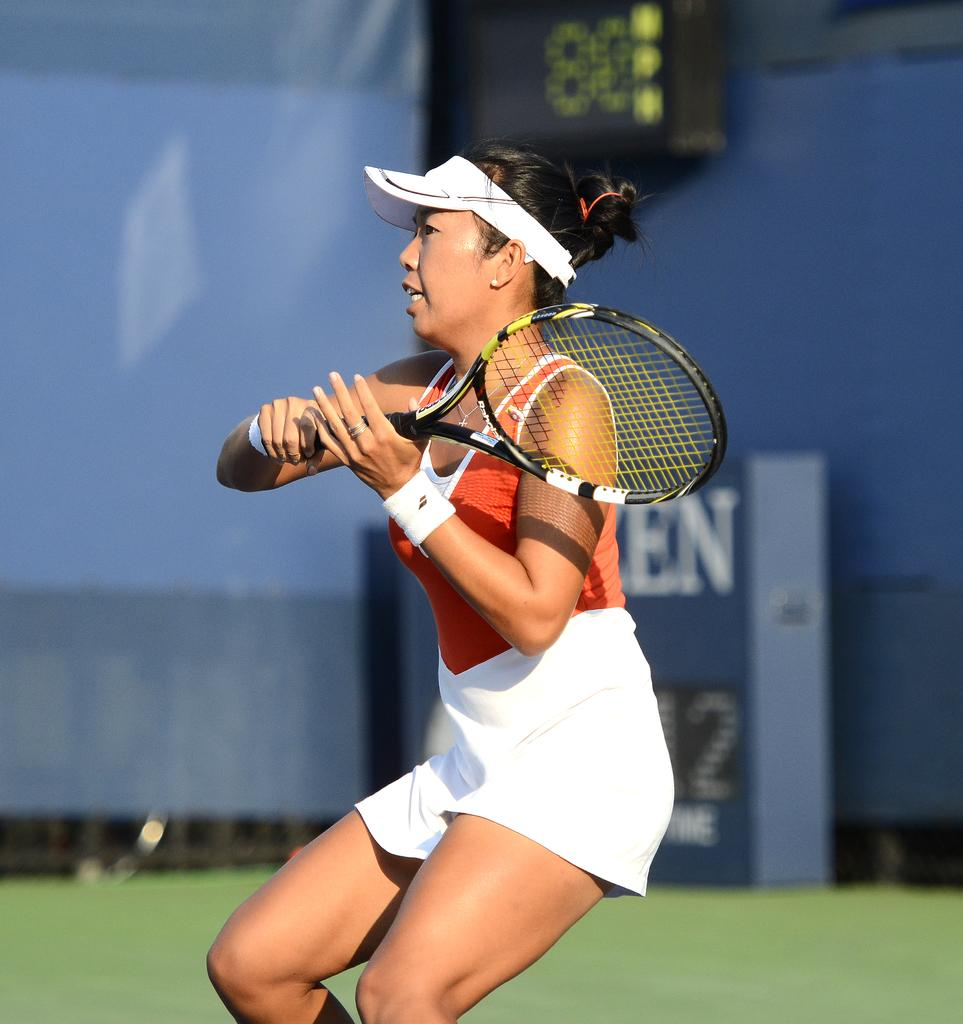Who is the main subject in the image? There is a woman in the image. What is the woman holding in the image? The woman is holding a racket. What activity is the woman engaged in? It appears that the woman is playing tennis. What can be seen in the background of the image? There is a wall and a digital display board in the background of the image. How many pizzas is the maid holding in the image? There is no maid or pizzas present in the image. What type of mint is growing near the digital display board? There is no mint visible in the image. 